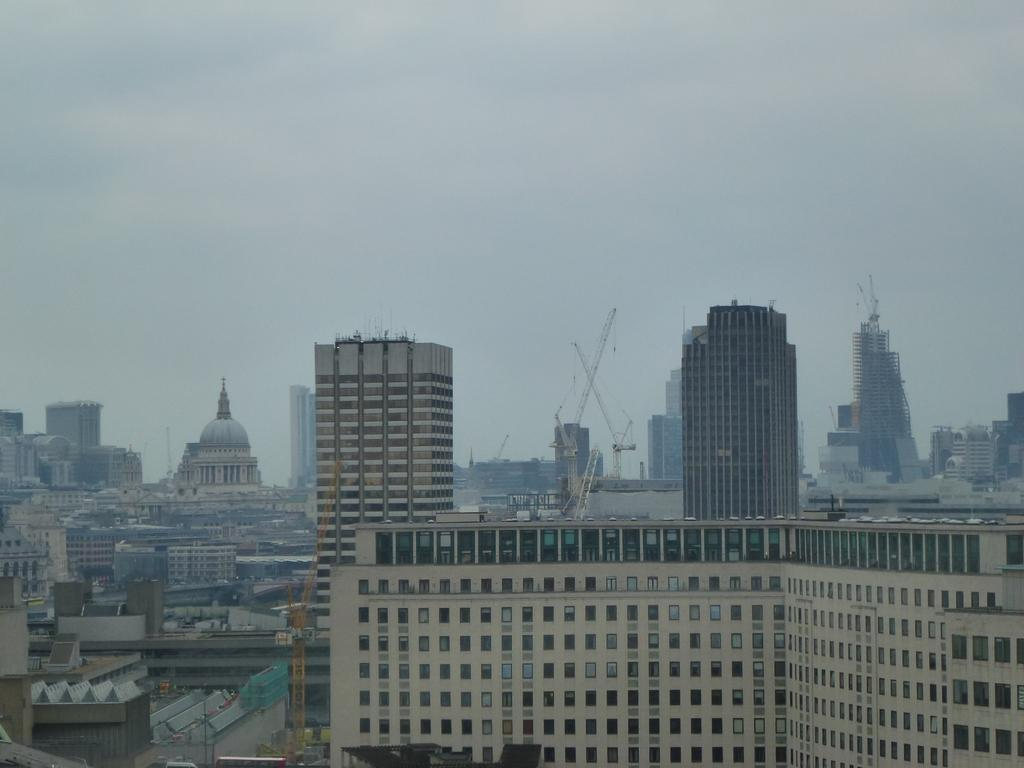What type of structures can be seen in the image? There are many buildings in the image. What else is present in the image besides the buildings? There are poles in the image. What can be seen in the background of the image? The sky is visible in the background of the image. What type of steam is coming out of the zebra in the image? There is no zebra present in the image, and therefore no steam coming out of it. 